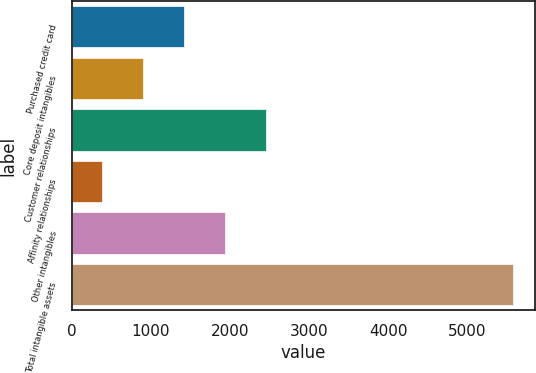Convert chart. <chart><loc_0><loc_0><loc_500><loc_500><bar_chart><fcel>Purchased credit card<fcel>Core deposit intangibles<fcel>Customer relationships<fcel>Affinity relationships<fcel>Other intangibles<fcel>Total intangible assets<nl><fcel>1417.2<fcel>897.6<fcel>2456.4<fcel>378<fcel>1936.8<fcel>5574<nl></chart> 